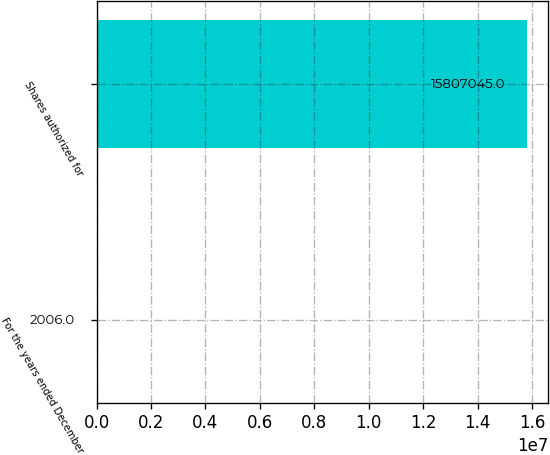<chart> <loc_0><loc_0><loc_500><loc_500><bar_chart><fcel>For the years ended December<fcel>Shares authorized for<nl><fcel>2006<fcel>1.5807e+07<nl></chart> 